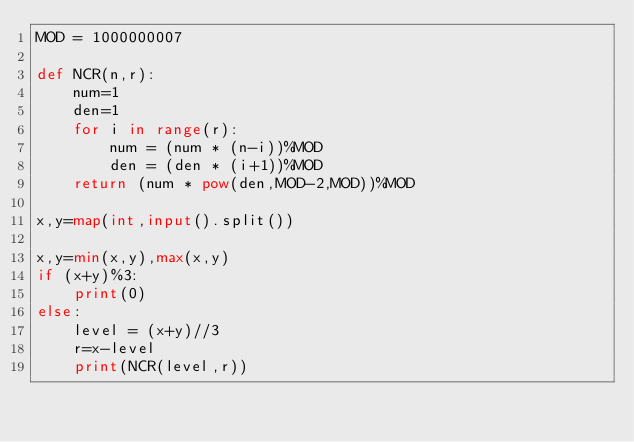<code> <loc_0><loc_0><loc_500><loc_500><_Python_>MOD = 1000000007

def NCR(n,r):
	num=1
	den=1
	for i in range(r):
		num = (num * (n-i))%MOD
		den = (den * (i+1))%MOD
	return (num * pow(den,MOD-2,MOD))%MOD

x,y=map(int,input().split())

x,y=min(x,y),max(x,y)
if (x+y)%3:
	print(0)
else:
	level = (x+y)//3
	r=x-level
	print(NCR(level,r))</code> 